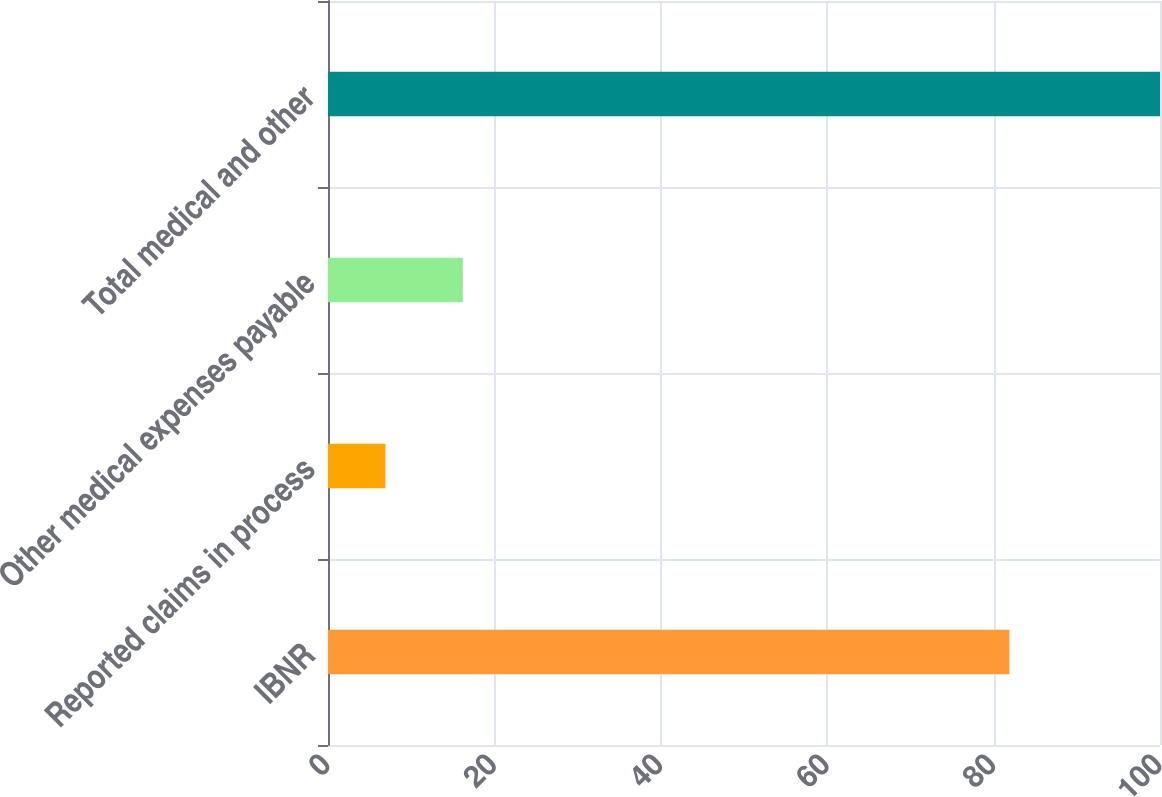Convert chart to OTSL. <chart><loc_0><loc_0><loc_500><loc_500><bar_chart><fcel>IBNR<fcel>Reported claims in process<fcel>Other medical expenses payable<fcel>Total medical and other<nl><fcel>81.9<fcel>6.9<fcel>16.21<fcel>100<nl></chart> 